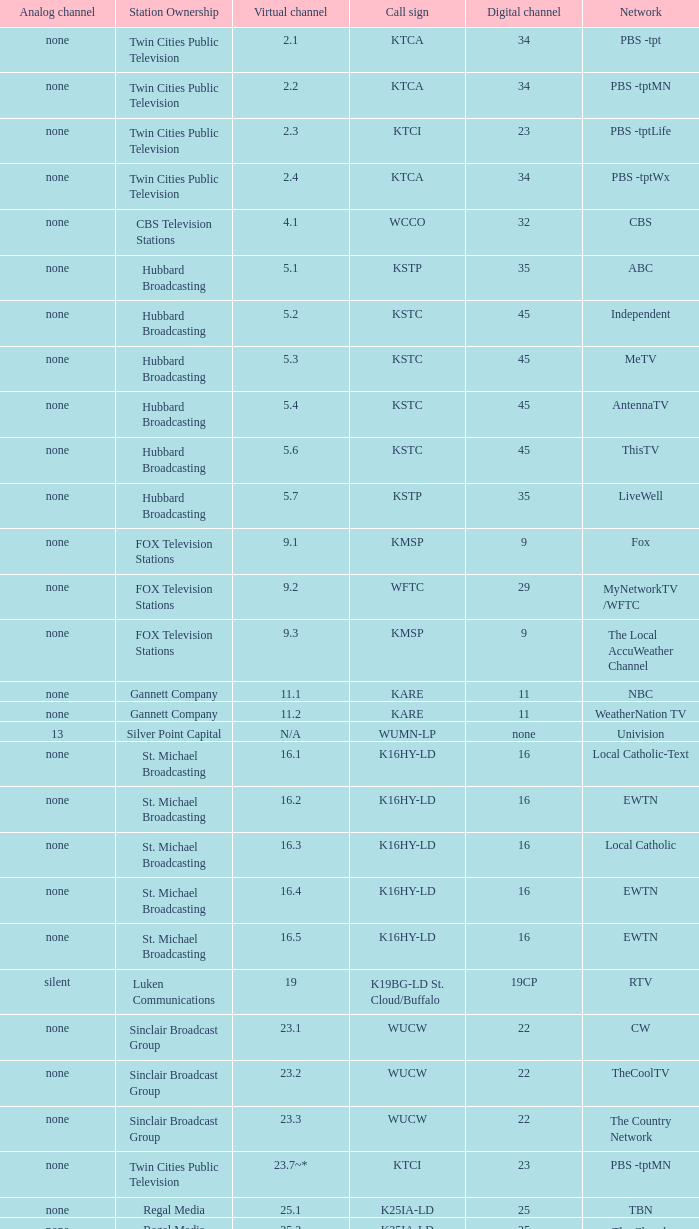Station Ownership of eicb tv, and a Call sign of ktcj-ld is what virtual network? 50.1. 